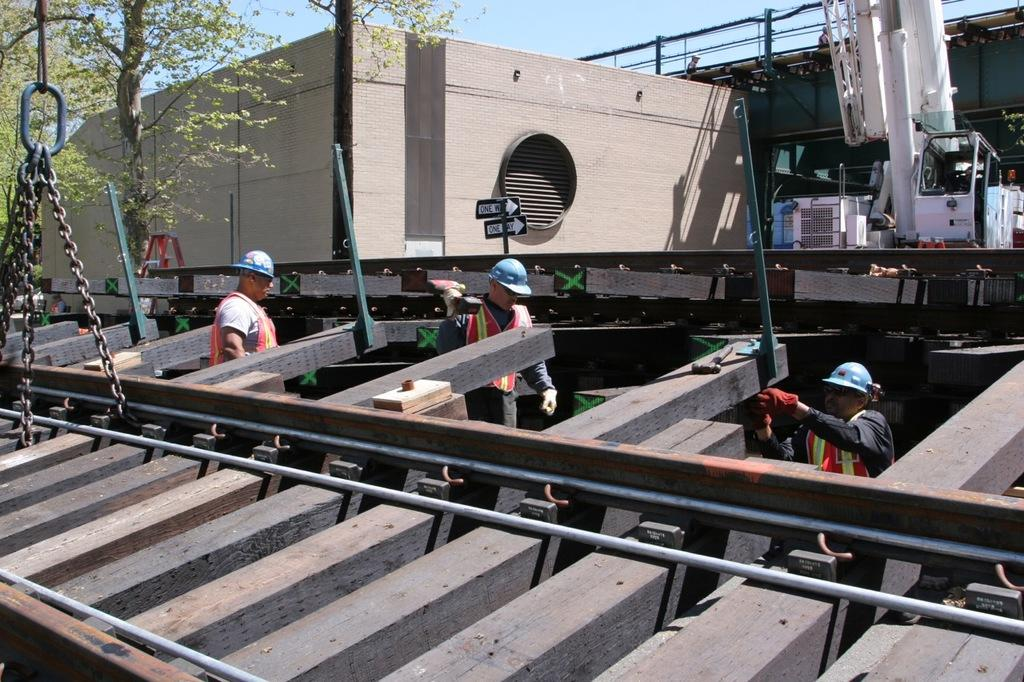What type of transportation infrastructure is shown in the image? There is a railway track in the image. What additional objects can be seen near the railway track? Chains, poles, and boards are visible in the image. How many people are present in the image? There are three persons in the image. What can be seen in the background of the image? Trees, a building, and the sky are visible in the background of the image. Can you describe the objects in the image? There are objects in the image, but their specific nature is not mentioned in the provided facts. How many pigs are being transported on the voyage depicted in the image? There are no pigs or any indication of a voyage in the image. What type of snakes can be seen slithering in the image? There are no snakes present in the image. 